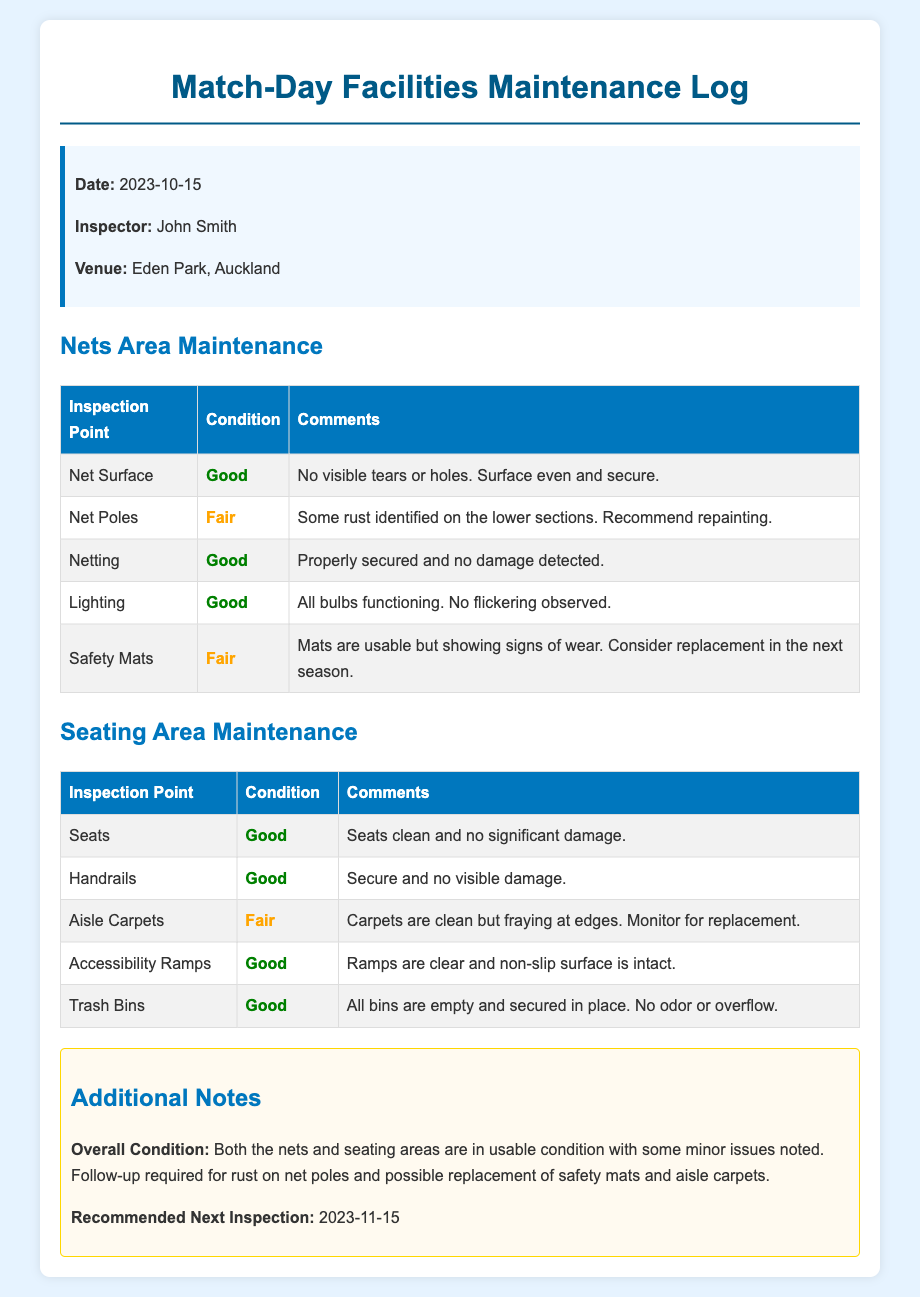What is the date of the inspection? The date is specified at the top of the document, indicating when the inspection took place.
Answer: 2023-10-15 Who conducted the inspection? The inspector's name is provided in the info box within the document.
Answer: John Smith Where was the inspection conducted? The venue where the inspection took place is listed in the info box.
Answer: Eden Park, Auckland What is the condition of the net surface? The condition of the net surface is noted in the Nets Area Maintenance table.
Answer: Good What major issue was noted for the safety mats? The comments regarding the safety mats detail the condition and recommendations for future action.
Answer: Signs of wear How many inspection points are listed for the seating area? The count of inspection points can be determined by counting the rows in the seating area maintenance table.
Answer: Five What is the recommended next inspection date? The next inspection date is noted in the additional notes section of the document.
Answer: 2023-11-15 What condition is indicated for the aisle carpets? The specific remarks on the condition of the aisle carpets are found in the Seating Area Maintenance table.
Answer: Fair What was identified as a recommendation for the net poles? The comments for the net poles mention a specific action to address the condition found.
Answer: Repainting 